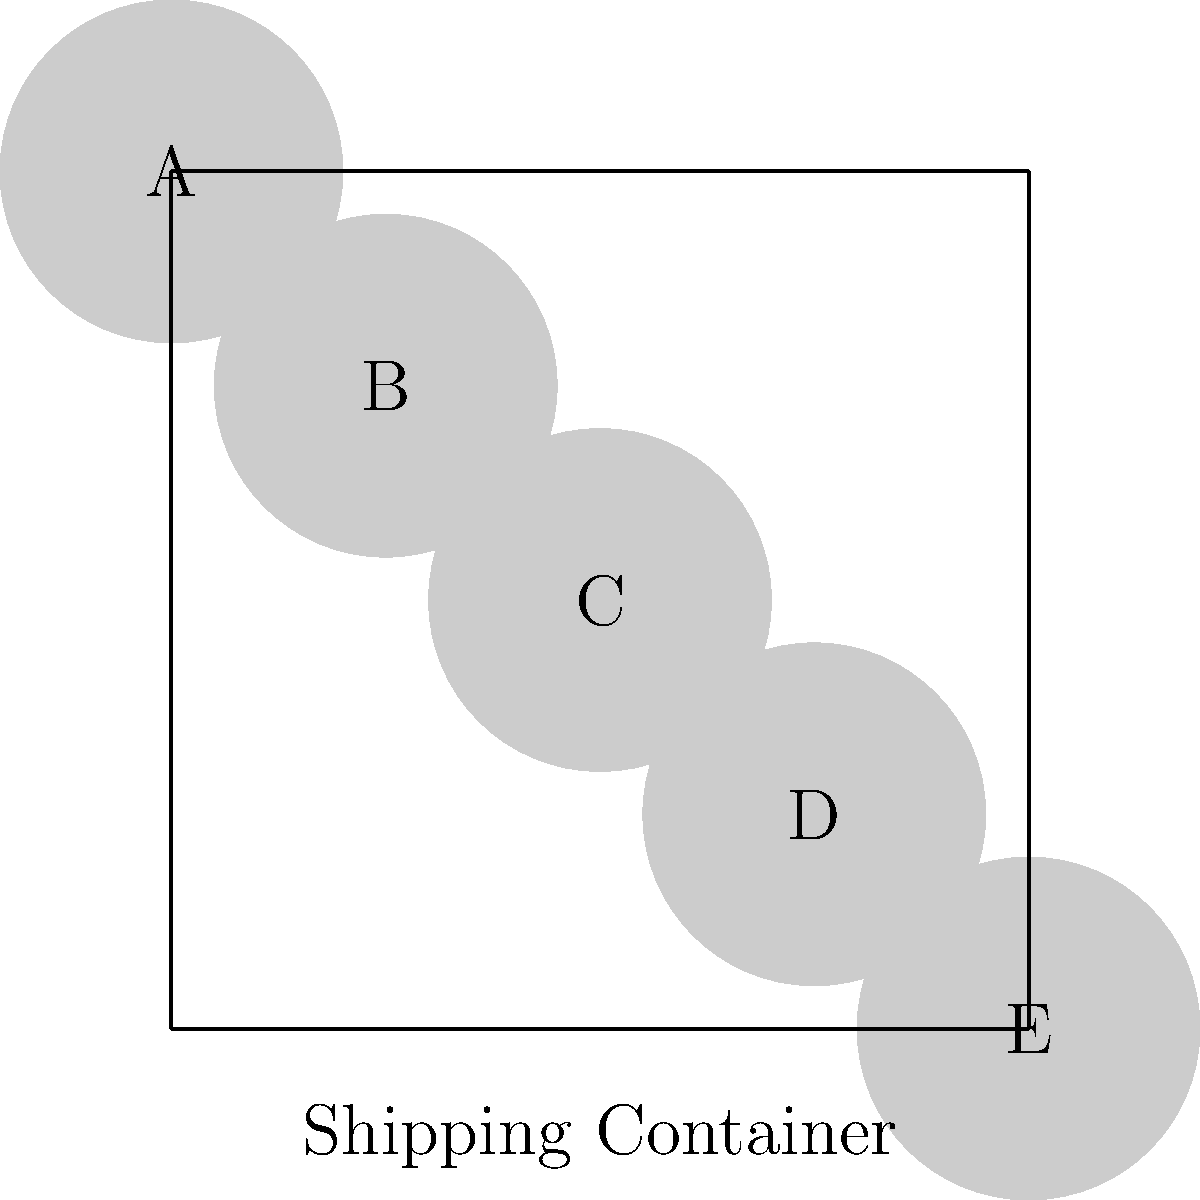A spice trader has a shipping container with 5 compartments arranged linearly. The trader needs to arrange 5 different spice blends (A, B, C, D, E) in these compartments. How many unique arrangements are possible if blends A and E must always be placed in compartments that are not adjacent to each other? Let's approach this step-by-step:

1) First, we need to understand what the question is asking. We have 5 spice blends to arrange in 5 compartments, with the constraint that A and E cannot be adjacent.

2) The total number of permutations of 5 items would normally be 5! = 120. However, we need to subtract the arrangements where A and E are adjacent.

3) To count the arrangements where A and E are adjacent:
   a) Consider A and E as a single unit. Now we have 4 units to arrange (AE, B, C, D).
   b) These 4 units can be arranged in 4! = 24 ways.
   c) For each of these arrangements, A and E can be swapped, doubling the count.

4) So, the number of arrangements with A and E adjacent is 24 * 2 = 48.

5) Therefore, the number of valid arrangements is:
   Total permutations - Arrangements with A and E adjacent
   = 5! - 48
   = 120 - 48
   = 72

Thus, there are 72 unique arrangements possible under the given constraints.
Answer: 72 